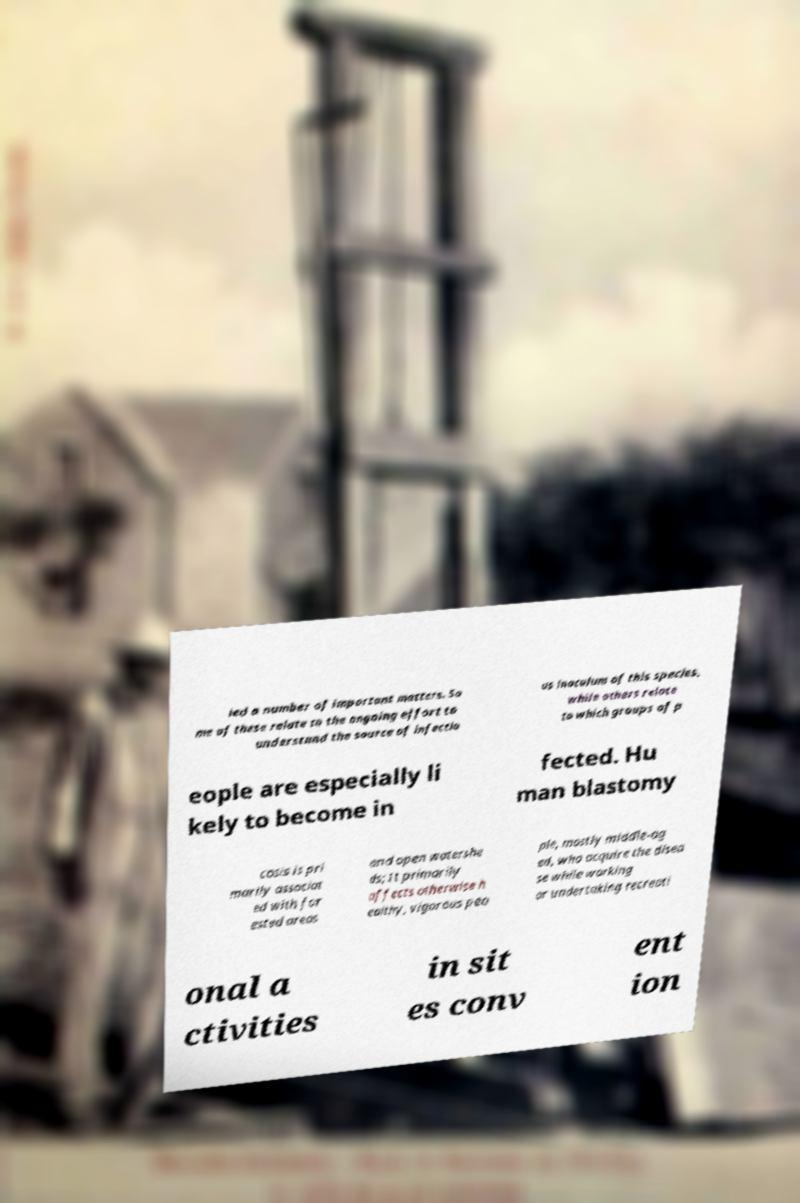What messages or text are displayed in this image? I need them in a readable, typed format. ied a number of important matters. So me of these relate to the ongoing effort to understand the source of infectio us inoculum of this species, while others relate to which groups of p eople are especially li kely to become in fected. Hu man blastomy cosis is pri marily associat ed with for ested areas and open watershe ds; It primarily affects otherwise h ealthy, vigorous peo ple, mostly middle-ag ed, who acquire the disea se while working or undertaking recreati onal a ctivities in sit es conv ent ion 